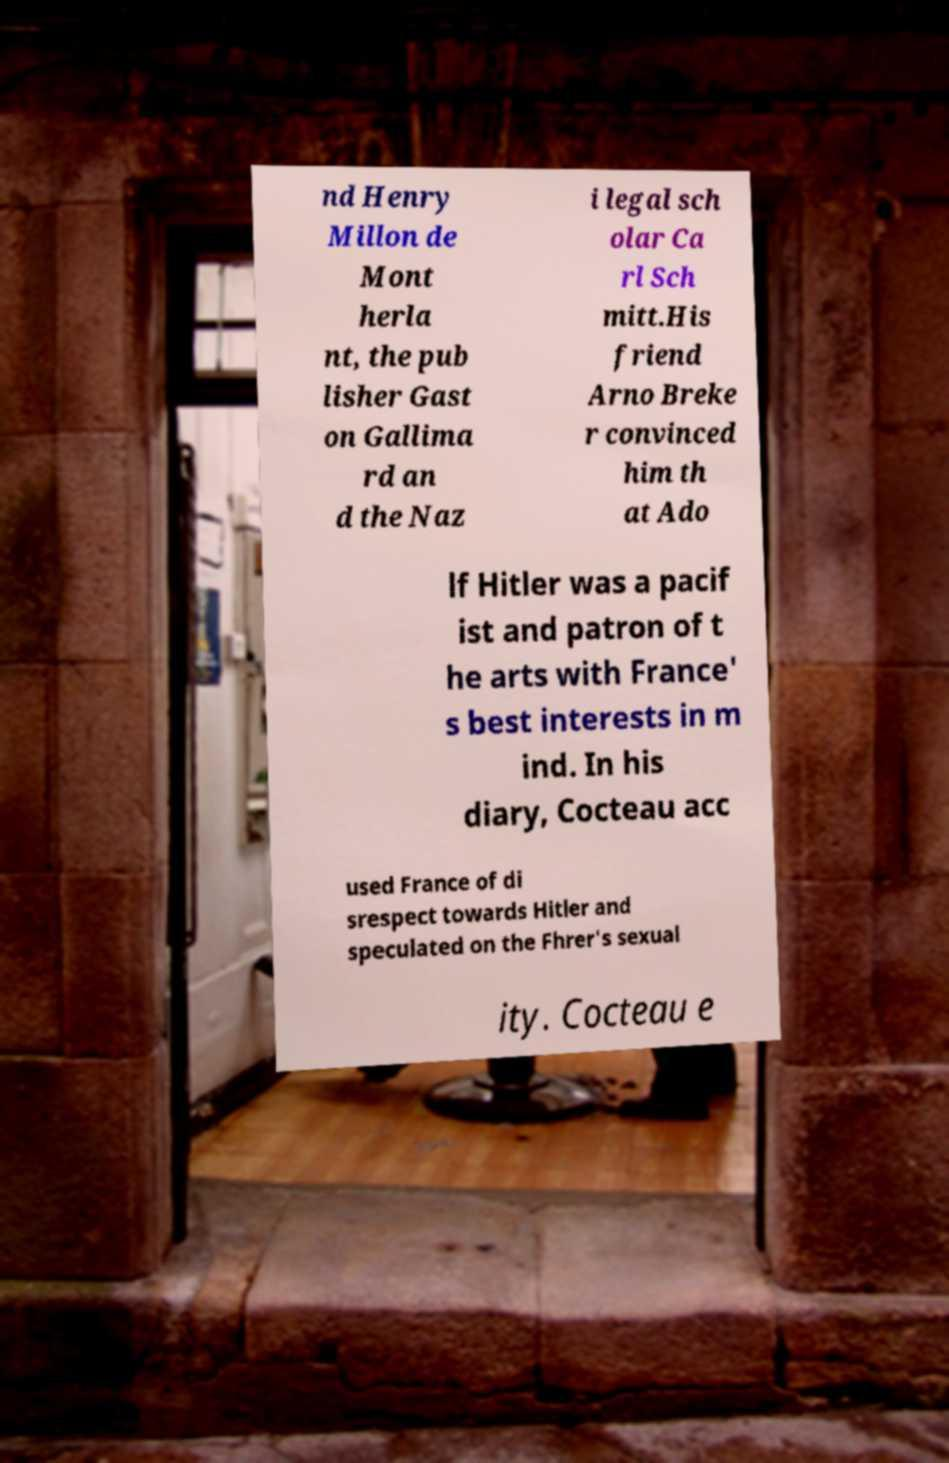For documentation purposes, I need the text within this image transcribed. Could you provide that? nd Henry Millon de Mont herla nt, the pub lisher Gast on Gallima rd an d the Naz i legal sch olar Ca rl Sch mitt.His friend Arno Breke r convinced him th at Ado lf Hitler was a pacif ist and patron of t he arts with France' s best interests in m ind. In his diary, Cocteau acc used France of di srespect towards Hitler and speculated on the Fhrer's sexual ity. Cocteau e 